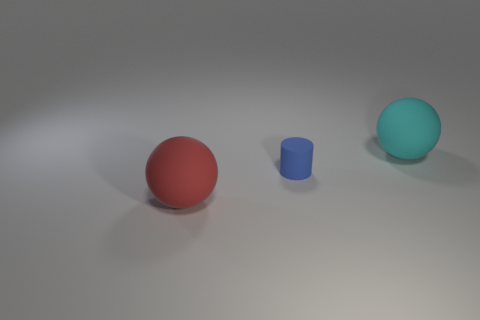Add 1 large gray rubber objects. How many objects exist? 4 Subtract all cylinders. How many objects are left? 2 Add 2 large red spheres. How many large red spheres are left? 3 Add 1 tiny purple matte blocks. How many tiny purple matte blocks exist? 1 Subtract 0 green blocks. How many objects are left? 3 Subtract all red matte balls. Subtract all cyan matte objects. How many objects are left? 1 